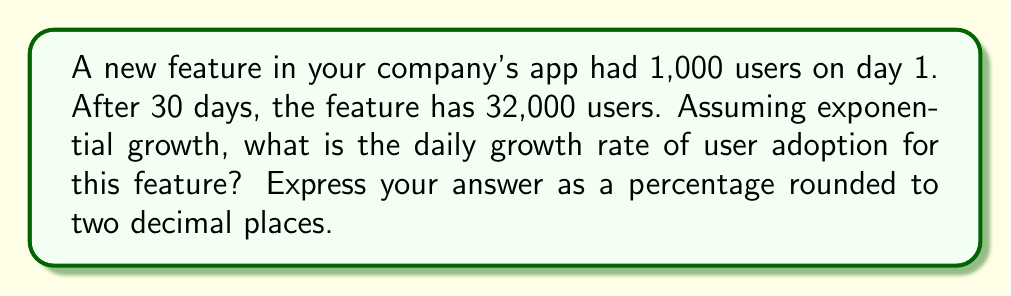Can you solve this math problem? Let's approach this step-by-step:

1) The exponential growth formula is:
   $$A = P(1 + r)^t$$
   Where:
   $A$ = Final amount
   $P$ = Initial amount
   $r$ = Daily growth rate (as a decimal)
   $t$ = Number of days

2) We know:
   $A = 32,000$
   $P = 1,000$
   $t = 30$

3) Substituting these values:
   $$32,000 = 1,000(1 + r)^{30}$$

4) Dividing both sides by 1,000:
   $$32 = (1 + r)^{30}$$

5) Taking the 30th root of both sides:
   $$\sqrt[30]{32} = 1 + r$$

6) Solving for $r$:
   $$r = \sqrt[30]{32} - 1$$

7) Calculate this value:
   $$r \approx 0.1166$$

8) Convert to a percentage by multiplying by 100:
   $$r \approx 11.66\%$$

9) Rounding to two decimal places:
   $$r \approx 11.66\%$$
Answer: 11.66% 